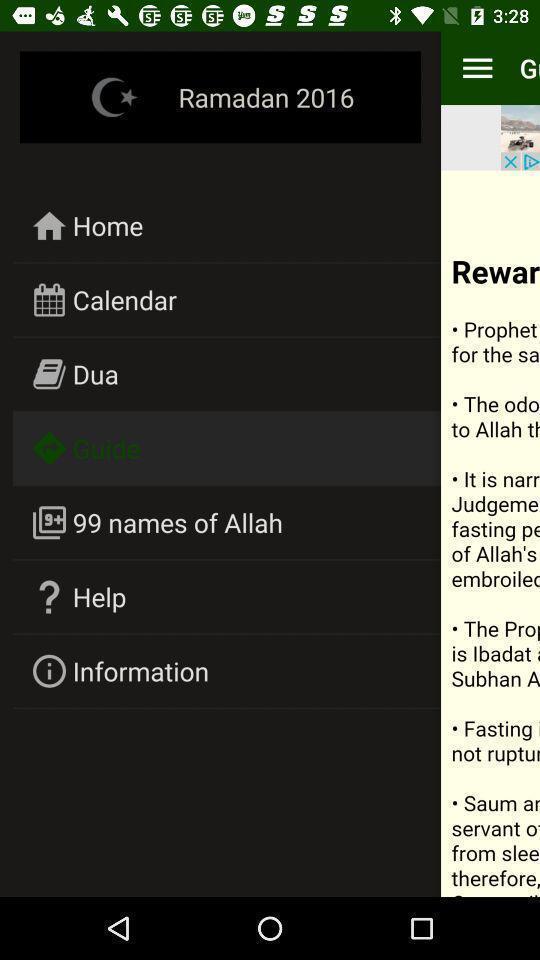Summarize the main components in this picture. Page with guide option selected. 